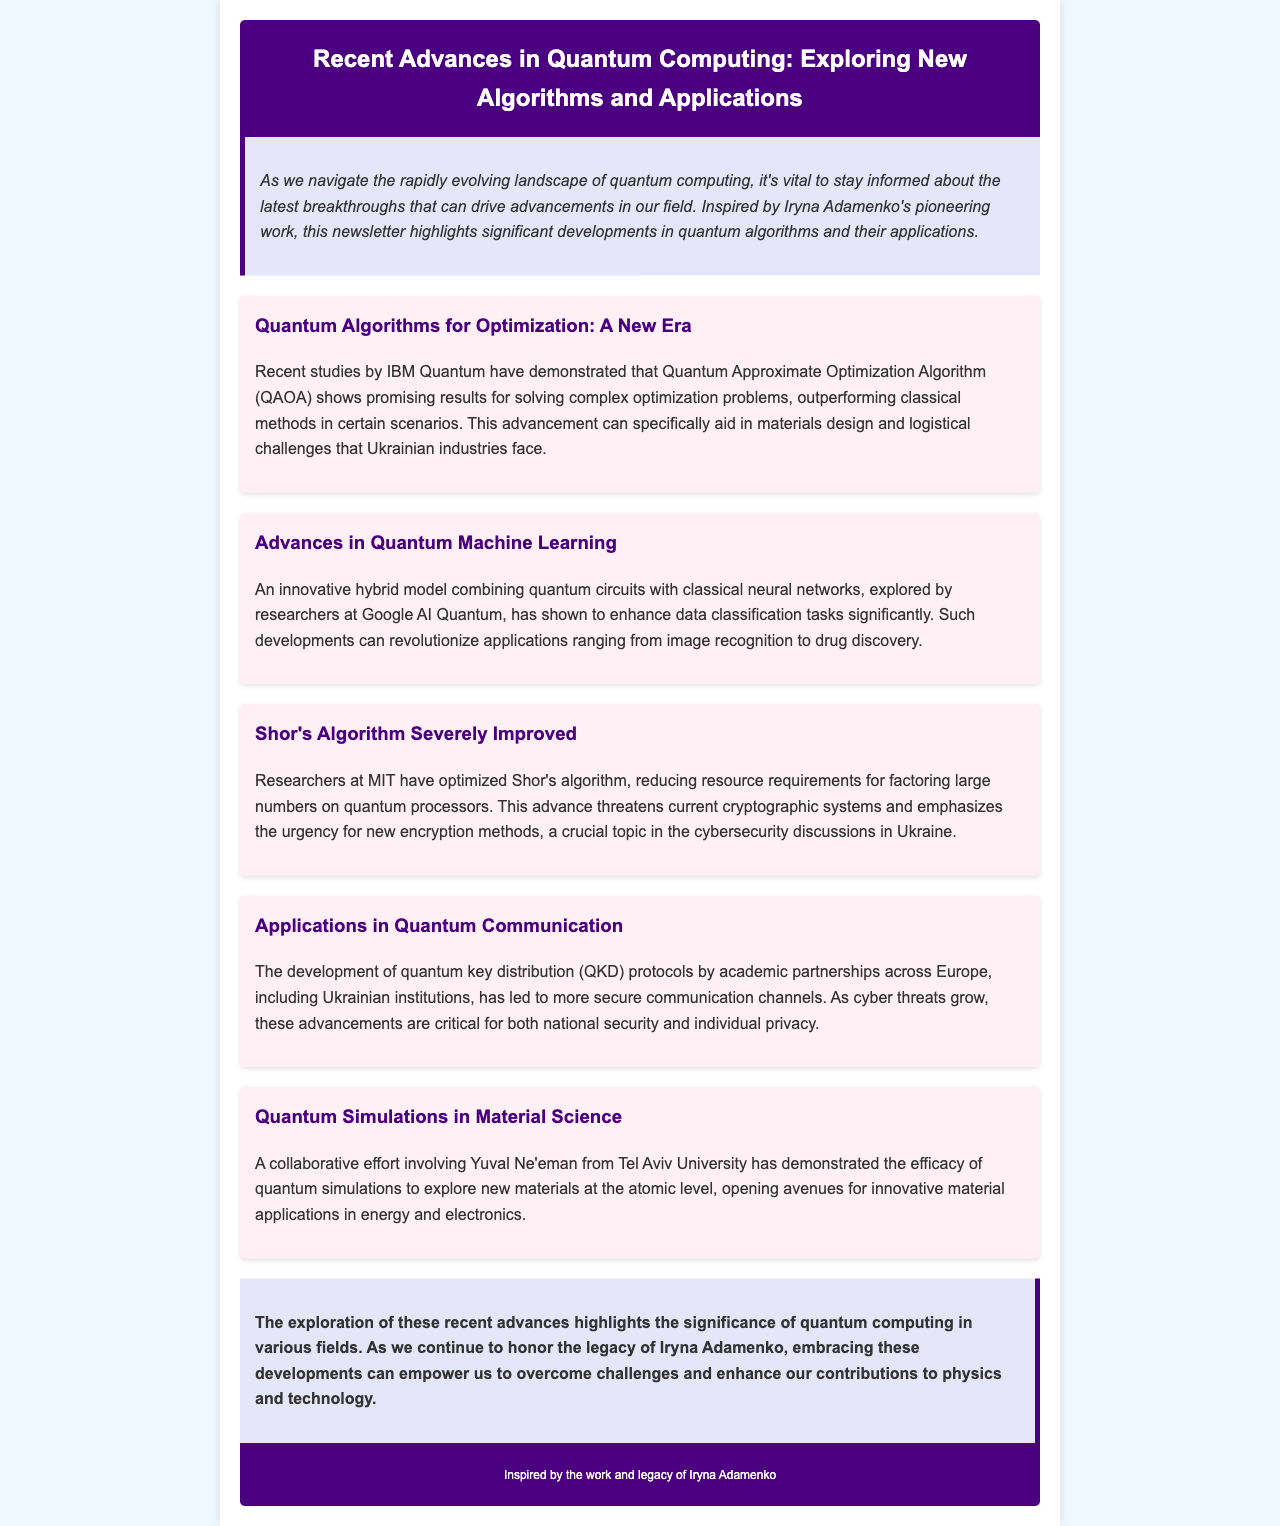What is the title of the newsletter? The title is presented at the top of the document in the header section, which is "Recent Advances in Quantum Computing: Exploring New Algorithms and Applications."
Answer: Recent Advances in Quantum Computing: Exploring New Algorithms and Applications Who demonstrated promising results for QAOA? The document states that studies by IBM Quantum have demonstrated promising results for QAOA.
Answer: IBM Quantum What type of model was explored by researchers at Google AI Quantum? The document describes the innovative hybrid model as combining quantum circuits with classical neural networks.
Answer: hybrid model What does the optimization of Shor's algorithm threaten? The text indicates that the optimization of Shor's algorithm threatens current cryptographic systems.
Answer: current cryptographic systems Which protocol has been developed for more secure communication channels? The document refers to the development of quantum key distribution (QKD) protocols.
Answer: quantum key distribution (QKD) Which university is Yuval Ne'eman associated with? The document explicitly mentions that Yuval Ne'eman is from Tel Aviv University.
Answer: Tel Aviv University What is the background color of the introduction section? The document specifies that the background color of the introduction section is #e6e6fa.
Answer: #e6e6fa What legacy does the newsletter honor? The conclusion section of the document states that it honors the legacy of Iryna Adamenko.
Answer: Iryna Adamenko 